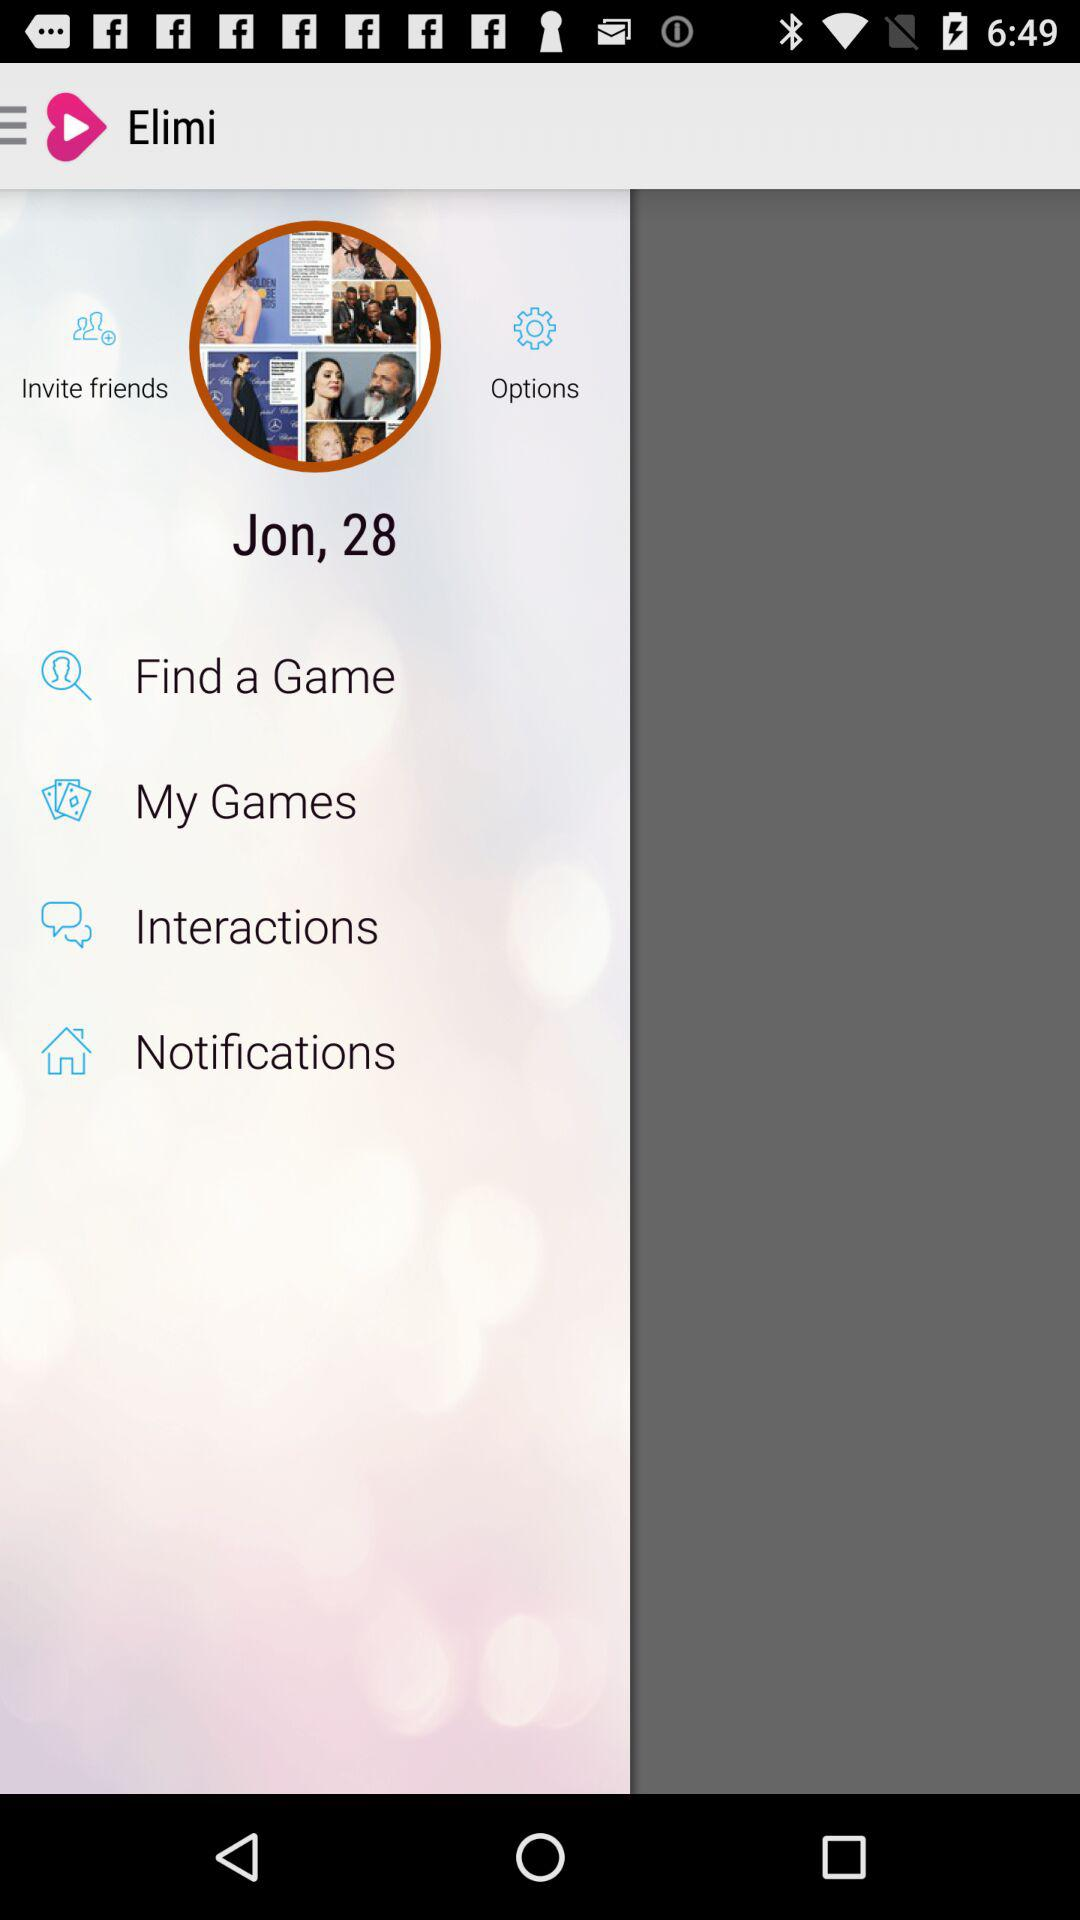What is the application name? The application name is "Elimi". 